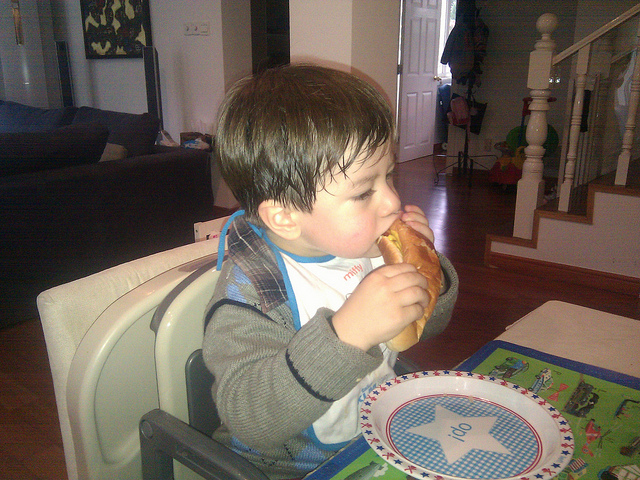Identify and read out the text in this image. OP! 